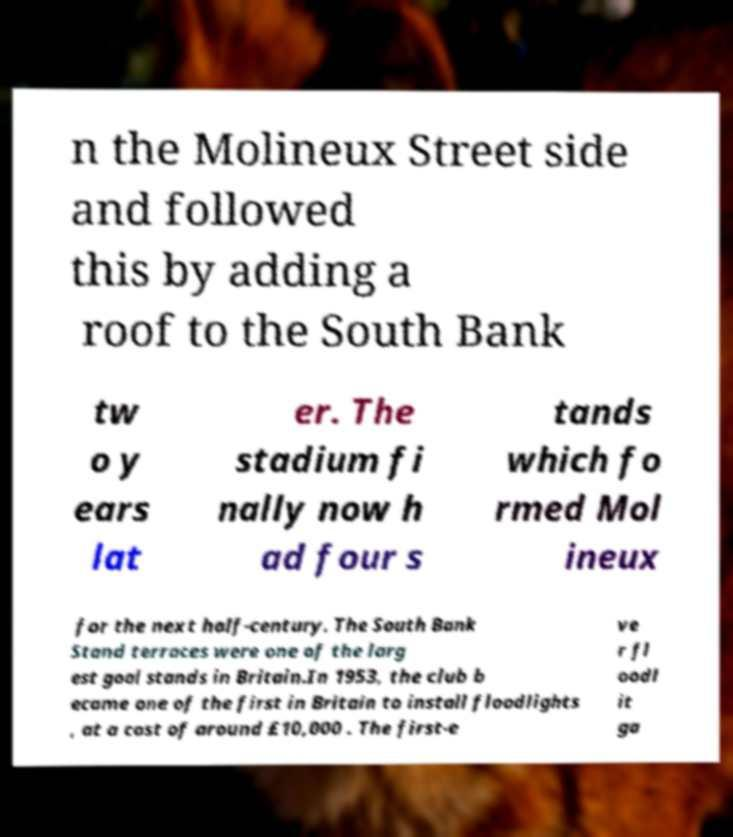Can you accurately transcribe the text from the provided image for me? n the Molineux Street side and followed this by adding a roof to the South Bank tw o y ears lat er. The stadium fi nally now h ad four s tands which fo rmed Mol ineux for the next half-century. The South Bank Stand terraces were one of the larg est goal stands in Britain.In 1953, the club b ecame one of the first in Britain to install floodlights , at a cost of around £10,000 . The first-e ve r fl oodl it ga 